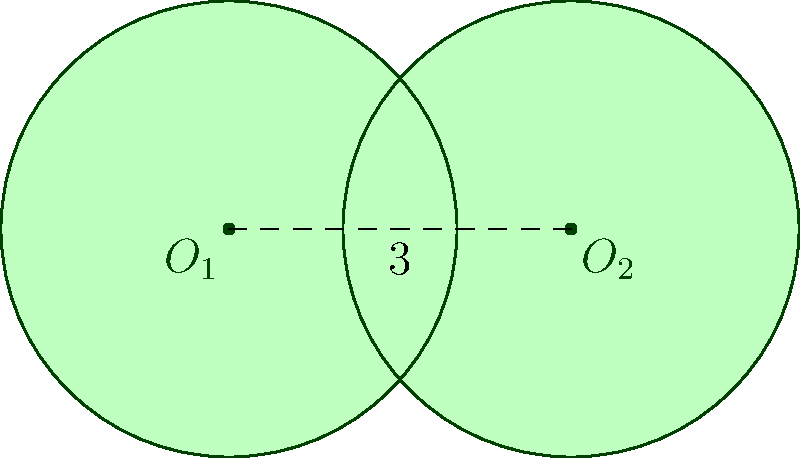In the diagram above, two circles with radius 2 units intersect, with their centers 3 units apart. The overlapping region forms a leaf-like shape. Calculate the area of this leaf-shaped region to the nearest hundredth of a square unit. Let's approach this step-by-step:

1) First, we need to find the angle of the sector in each circle that forms the leaf shape. We can do this using the cosine formula:

   $$\cos(\theta/2) = \frac{3/2}{2} = \frac{3}{4}$$

   $$\theta = 2 \arccos(\frac{3}{4}) \approx 1.5708 \text{ radians}$$

2) The area of a sector with angle $\theta$ in a circle of radius $r$ is given by:

   $$A_{sector} = \frac{1}{2}r^2\theta$$

3) Substituting our values:

   $$A_{sector} = \frac{1}{2} \cdot 2^2 \cdot 1.5708 \approx 3.1416$$

4) The leaf shape consists of two such sectors, so the total area of the sectors is:

   $$A_{total sectors} = 2 \cdot 3.1416 = 6.2832$$

5) However, this area includes the triangle formed by the centers of the circles and the intersection points. We need to subtract this triangle's area.

6) The height of this triangle is:

   $$h = \sqrt{2^2 - (3/2)^2} = \sqrt{4 - 2.25} = \sqrt{1.75} \approx 1.3229$$

7) The area of the triangle is:

   $$A_{triangle} = \frac{1}{2} \cdot 3 \cdot 1.3229 = 1.9843$$

8) Therefore, the area of the leaf shape is:

   $$A_{leaf} = A_{total sectors} - A_{triangle} = 6.2832 - 1.9843 = 4.2989$$

9) Rounding to the nearest hundredth:

   $$A_{leaf} \approx 4.30 \text{ square units}$$
Answer: 4.30 square units 